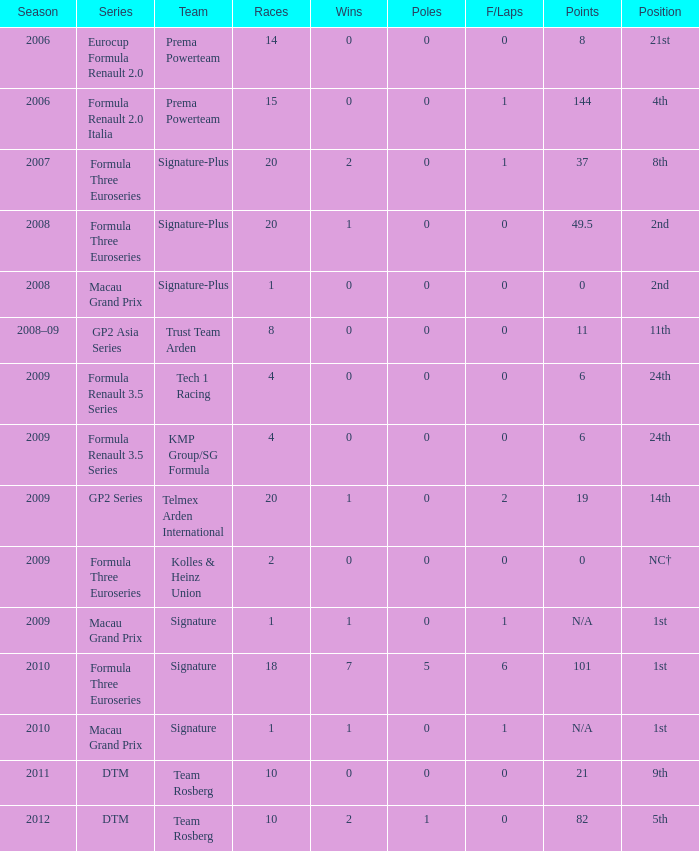What is the number of poles with greater than 0 fastest laps in the 2008 formula three euroseries season? None. 